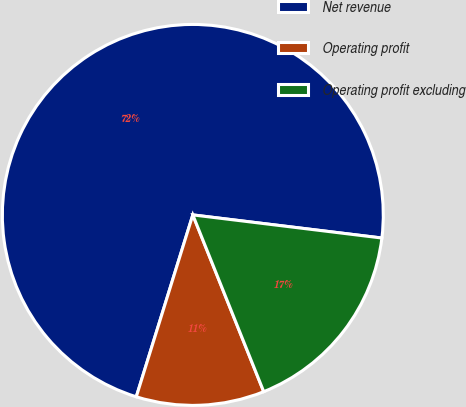Convert chart to OTSL. <chart><loc_0><loc_0><loc_500><loc_500><pie_chart><fcel>Net revenue<fcel>Operating profit<fcel>Operating profit excluding<nl><fcel>72.14%<fcel>10.87%<fcel>16.99%<nl></chart> 